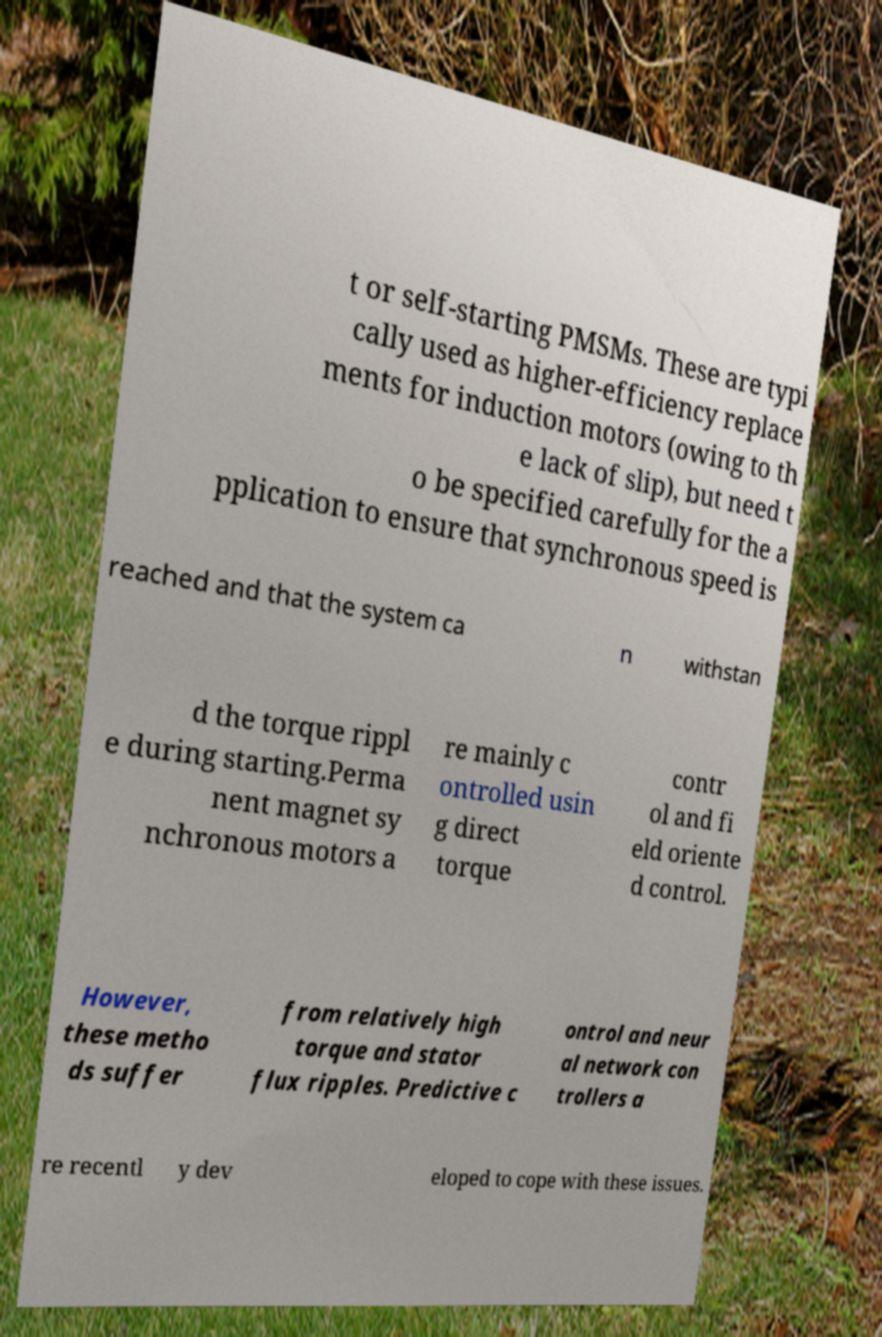Could you extract and type out the text from this image? t or self-starting PMSMs. These are typi cally used as higher-efficiency replace ments for induction motors (owing to th e lack of slip), but need t o be specified carefully for the a pplication to ensure that synchronous speed is reached and that the system ca n withstan d the torque rippl e during starting.Perma nent magnet sy nchronous motors a re mainly c ontrolled usin g direct torque contr ol and fi eld oriente d control. However, these metho ds suffer from relatively high torque and stator flux ripples. Predictive c ontrol and neur al network con trollers a re recentl y dev eloped to cope with these issues. 